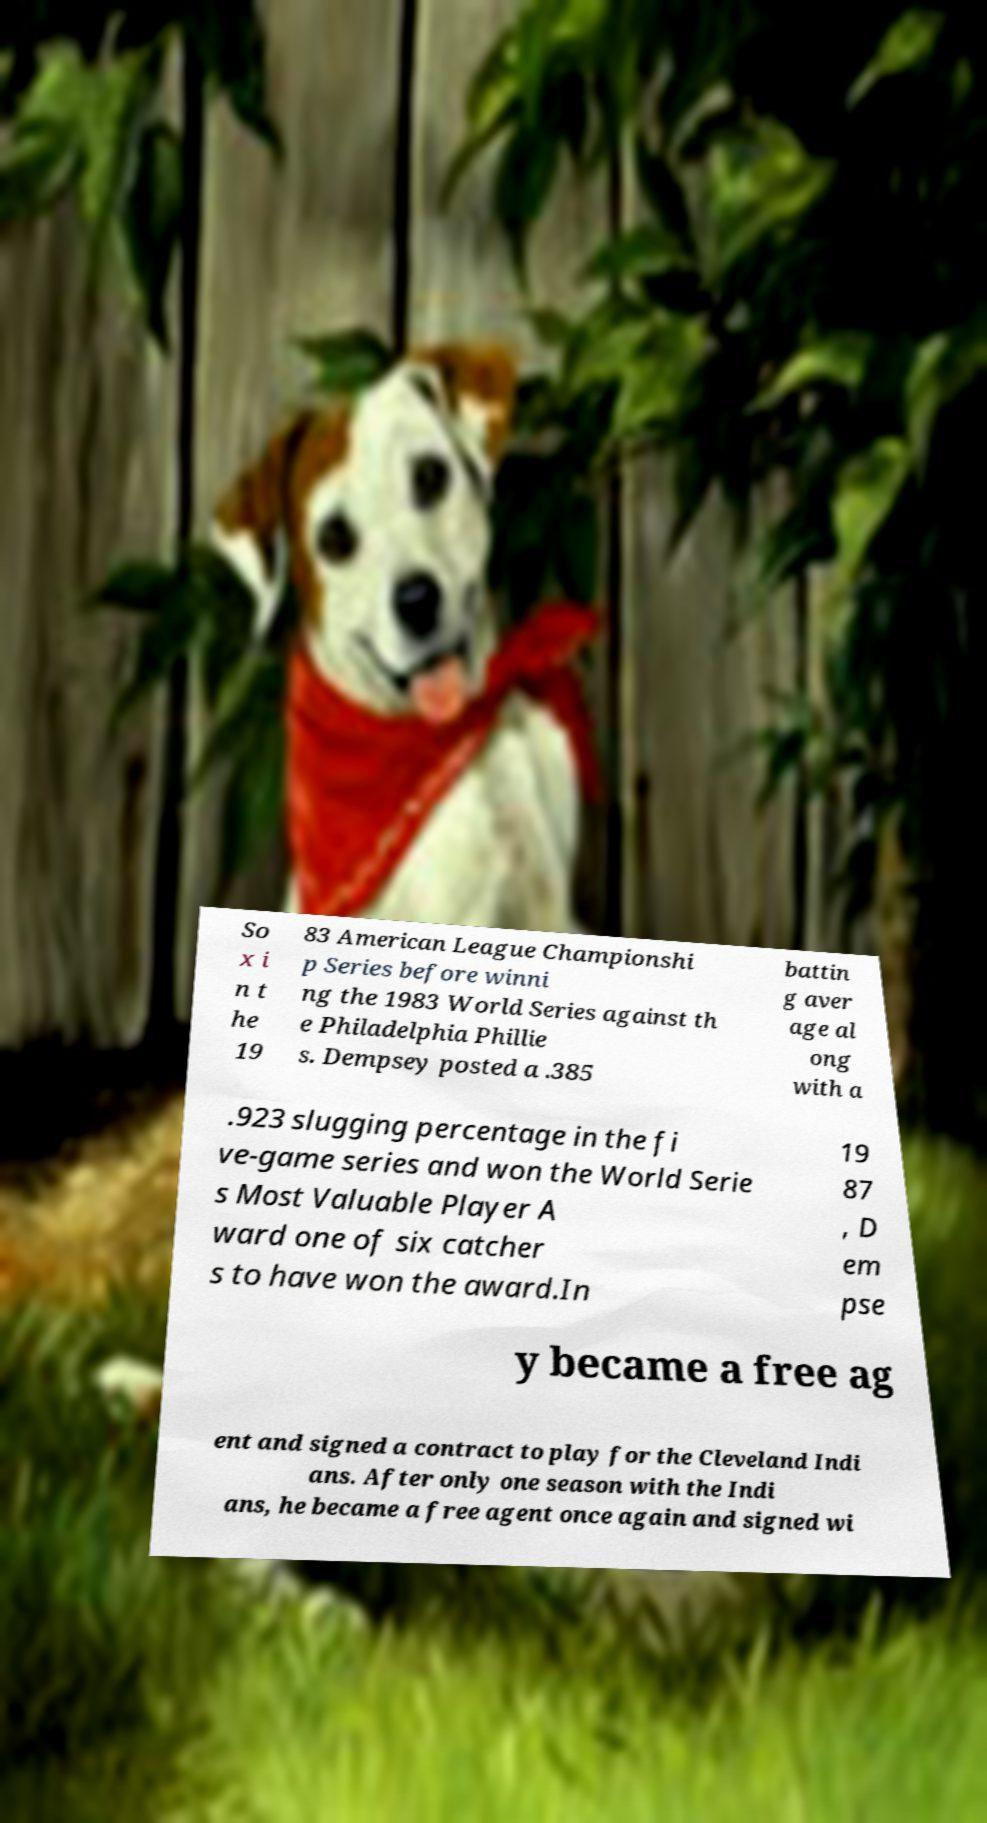Please identify and transcribe the text found in this image. So x i n t he 19 83 American League Championshi p Series before winni ng the 1983 World Series against th e Philadelphia Phillie s. Dempsey posted a .385 battin g aver age al ong with a .923 slugging percentage in the fi ve-game series and won the World Serie s Most Valuable Player A ward one of six catcher s to have won the award.In 19 87 , D em pse y became a free ag ent and signed a contract to play for the Cleveland Indi ans. After only one season with the Indi ans, he became a free agent once again and signed wi 